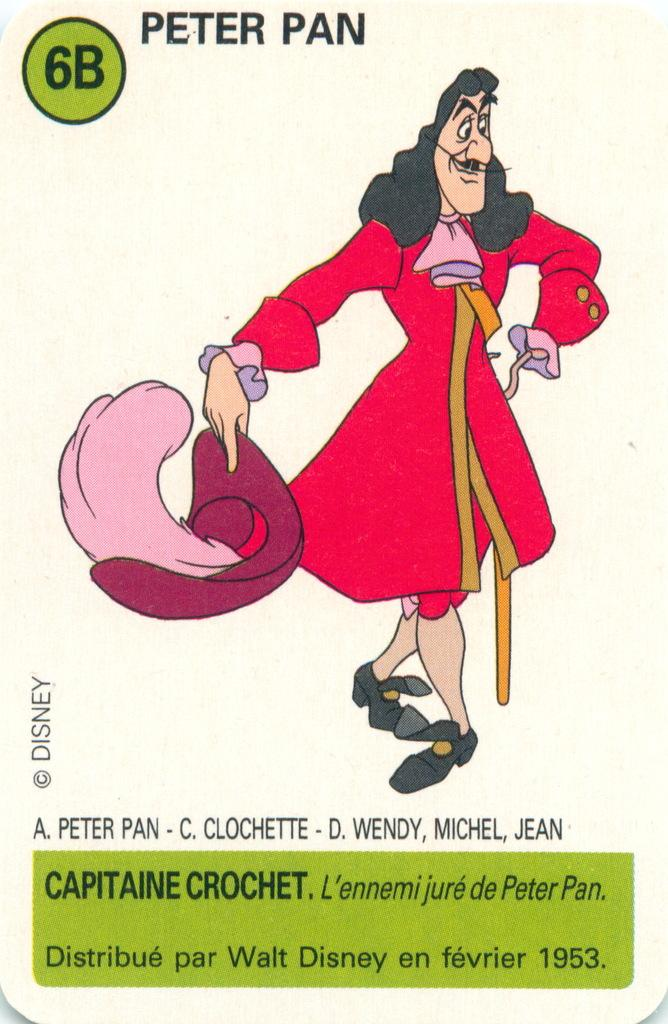What is the main subject of the picture? The main subject of the picture is a person. What is the person wearing in the image? The person is wearing a pink frock. What is the person's posture in the image? The person is standing. What can be seen above and below the image? There is something written above and below the image. What type of box is being used for a science experiment in the image? There is no box or science experiment present in the image; it features a person wearing a pink frock and standing. 